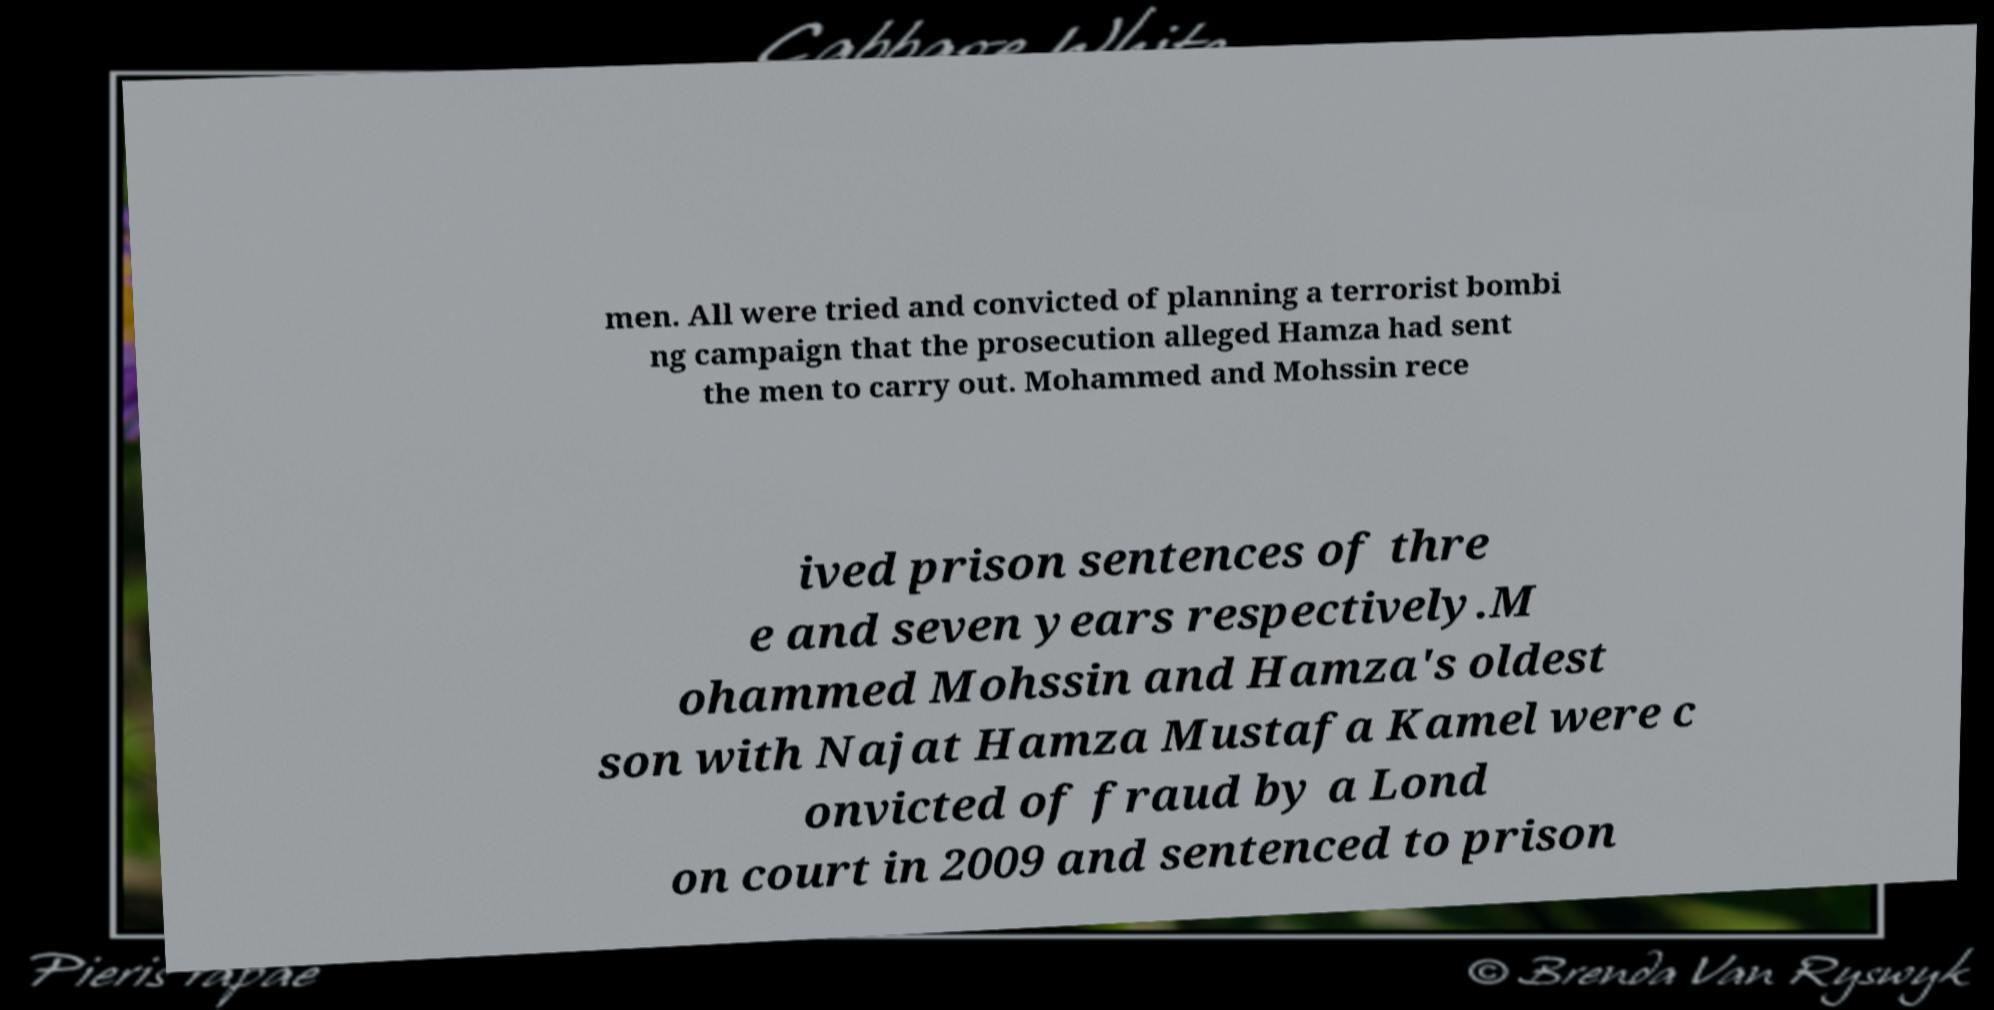Can you read and provide the text displayed in the image?This photo seems to have some interesting text. Can you extract and type it out for me? men. All were tried and convicted of planning a terrorist bombi ng campaign that the prosecution alleged Hamza had sent the men to carry out. Mohammed and Mohssin rece ived prison sentences of thre e and seven years respectively.M ohammed Mohssin and Hamza's oldest son with Najat Hamza Mustafa Kamel were c onvicted of fraud by a Lond on court in 2009 and sentenced to prison 